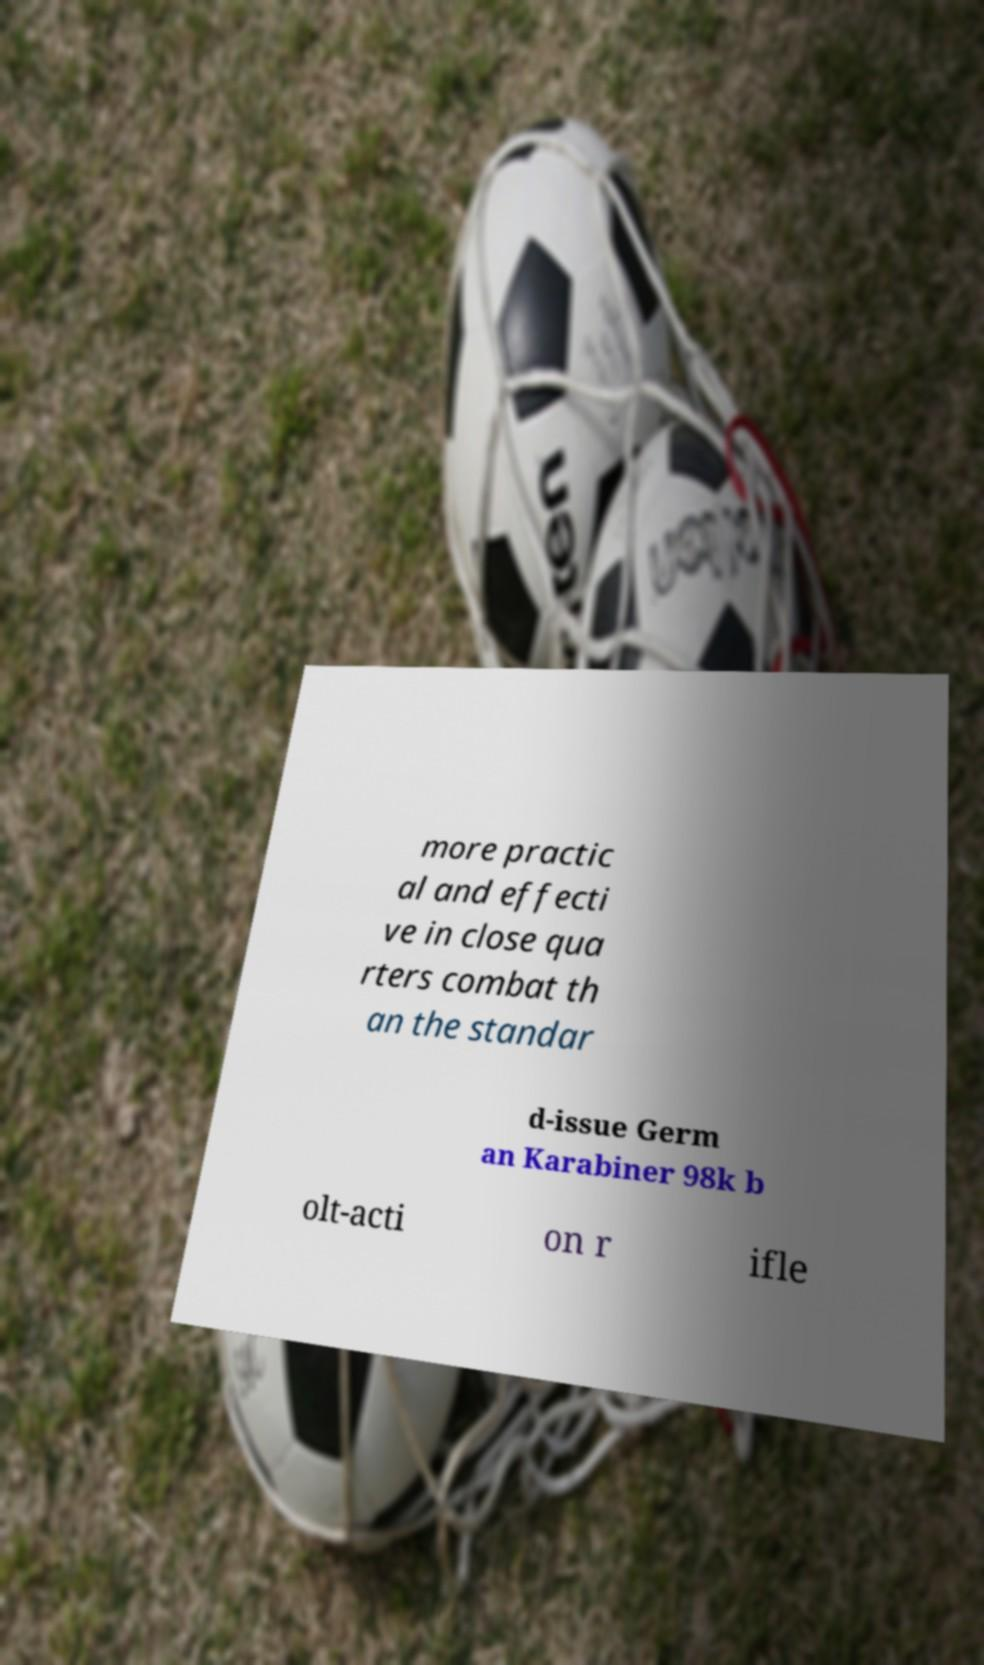Please identify and transcribe the text found in this image. more practic al and effecti ve in close qua rters combat th an the standar d-issue Germ an Karabiner 98k b olt-acti on r ifle 